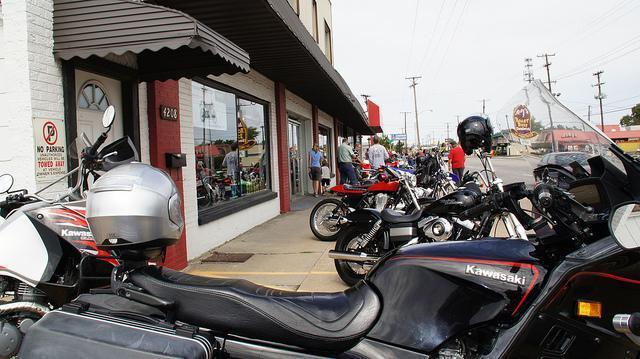How many motorcycles are visible?
Give a very brief answer. 4. How many other animals besides the giraffe are in the picture?
Give a very brief answer. 0. 